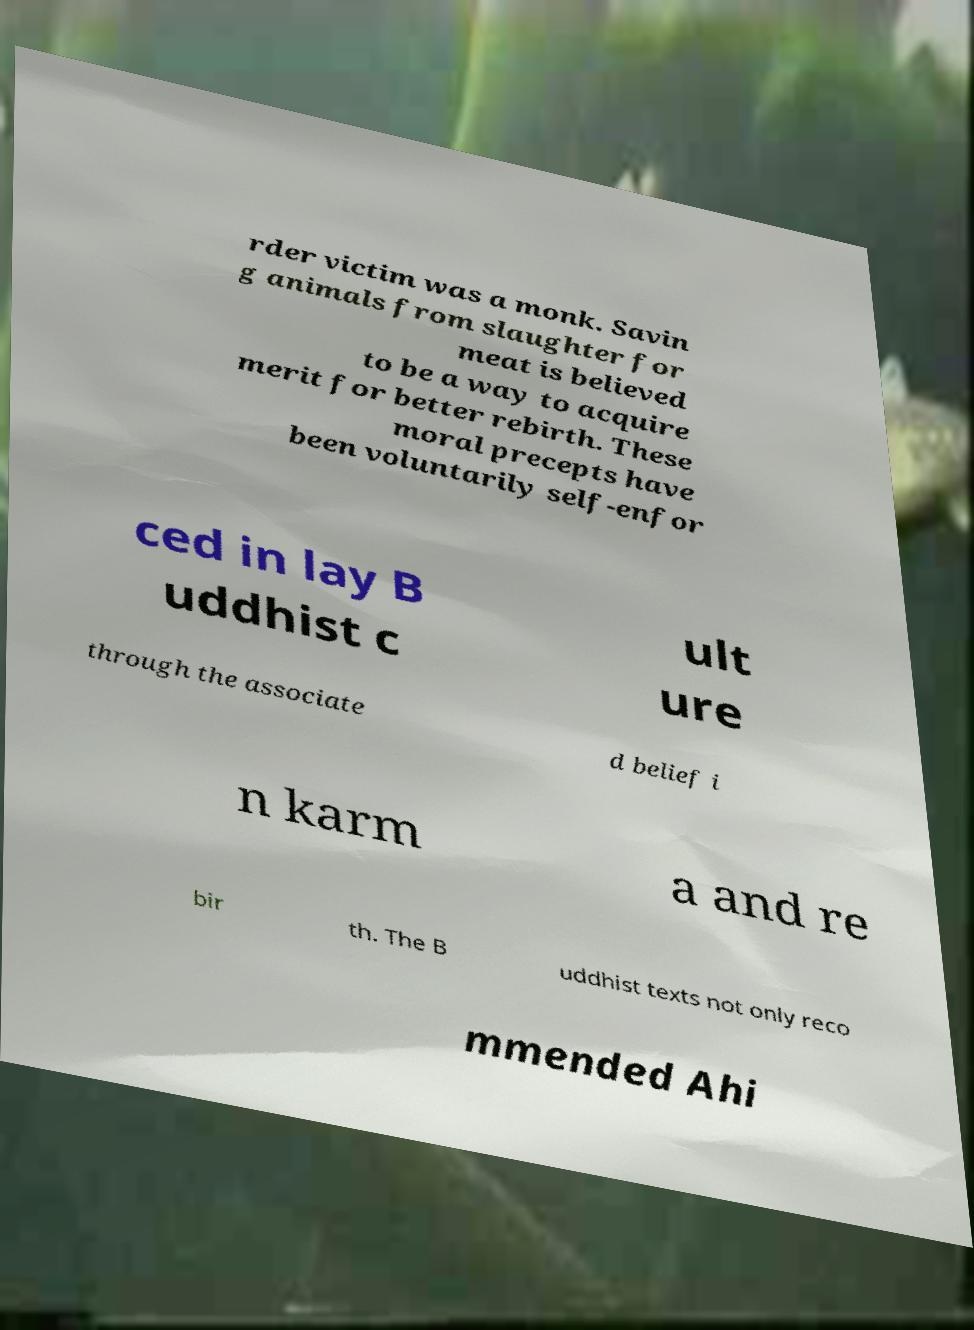Could you extract and type out the text from this image? rder victim was a monk. Savin g animals from slaughter for meat is believed to be a way to acquire merit for better rebirth. These moral precepts have been voluntarily self-enfor ced in lay B uddhist c ult ure through the associate d belief i n karm a and re bir th. The B uddhist texts not only reco mmended Ahi 